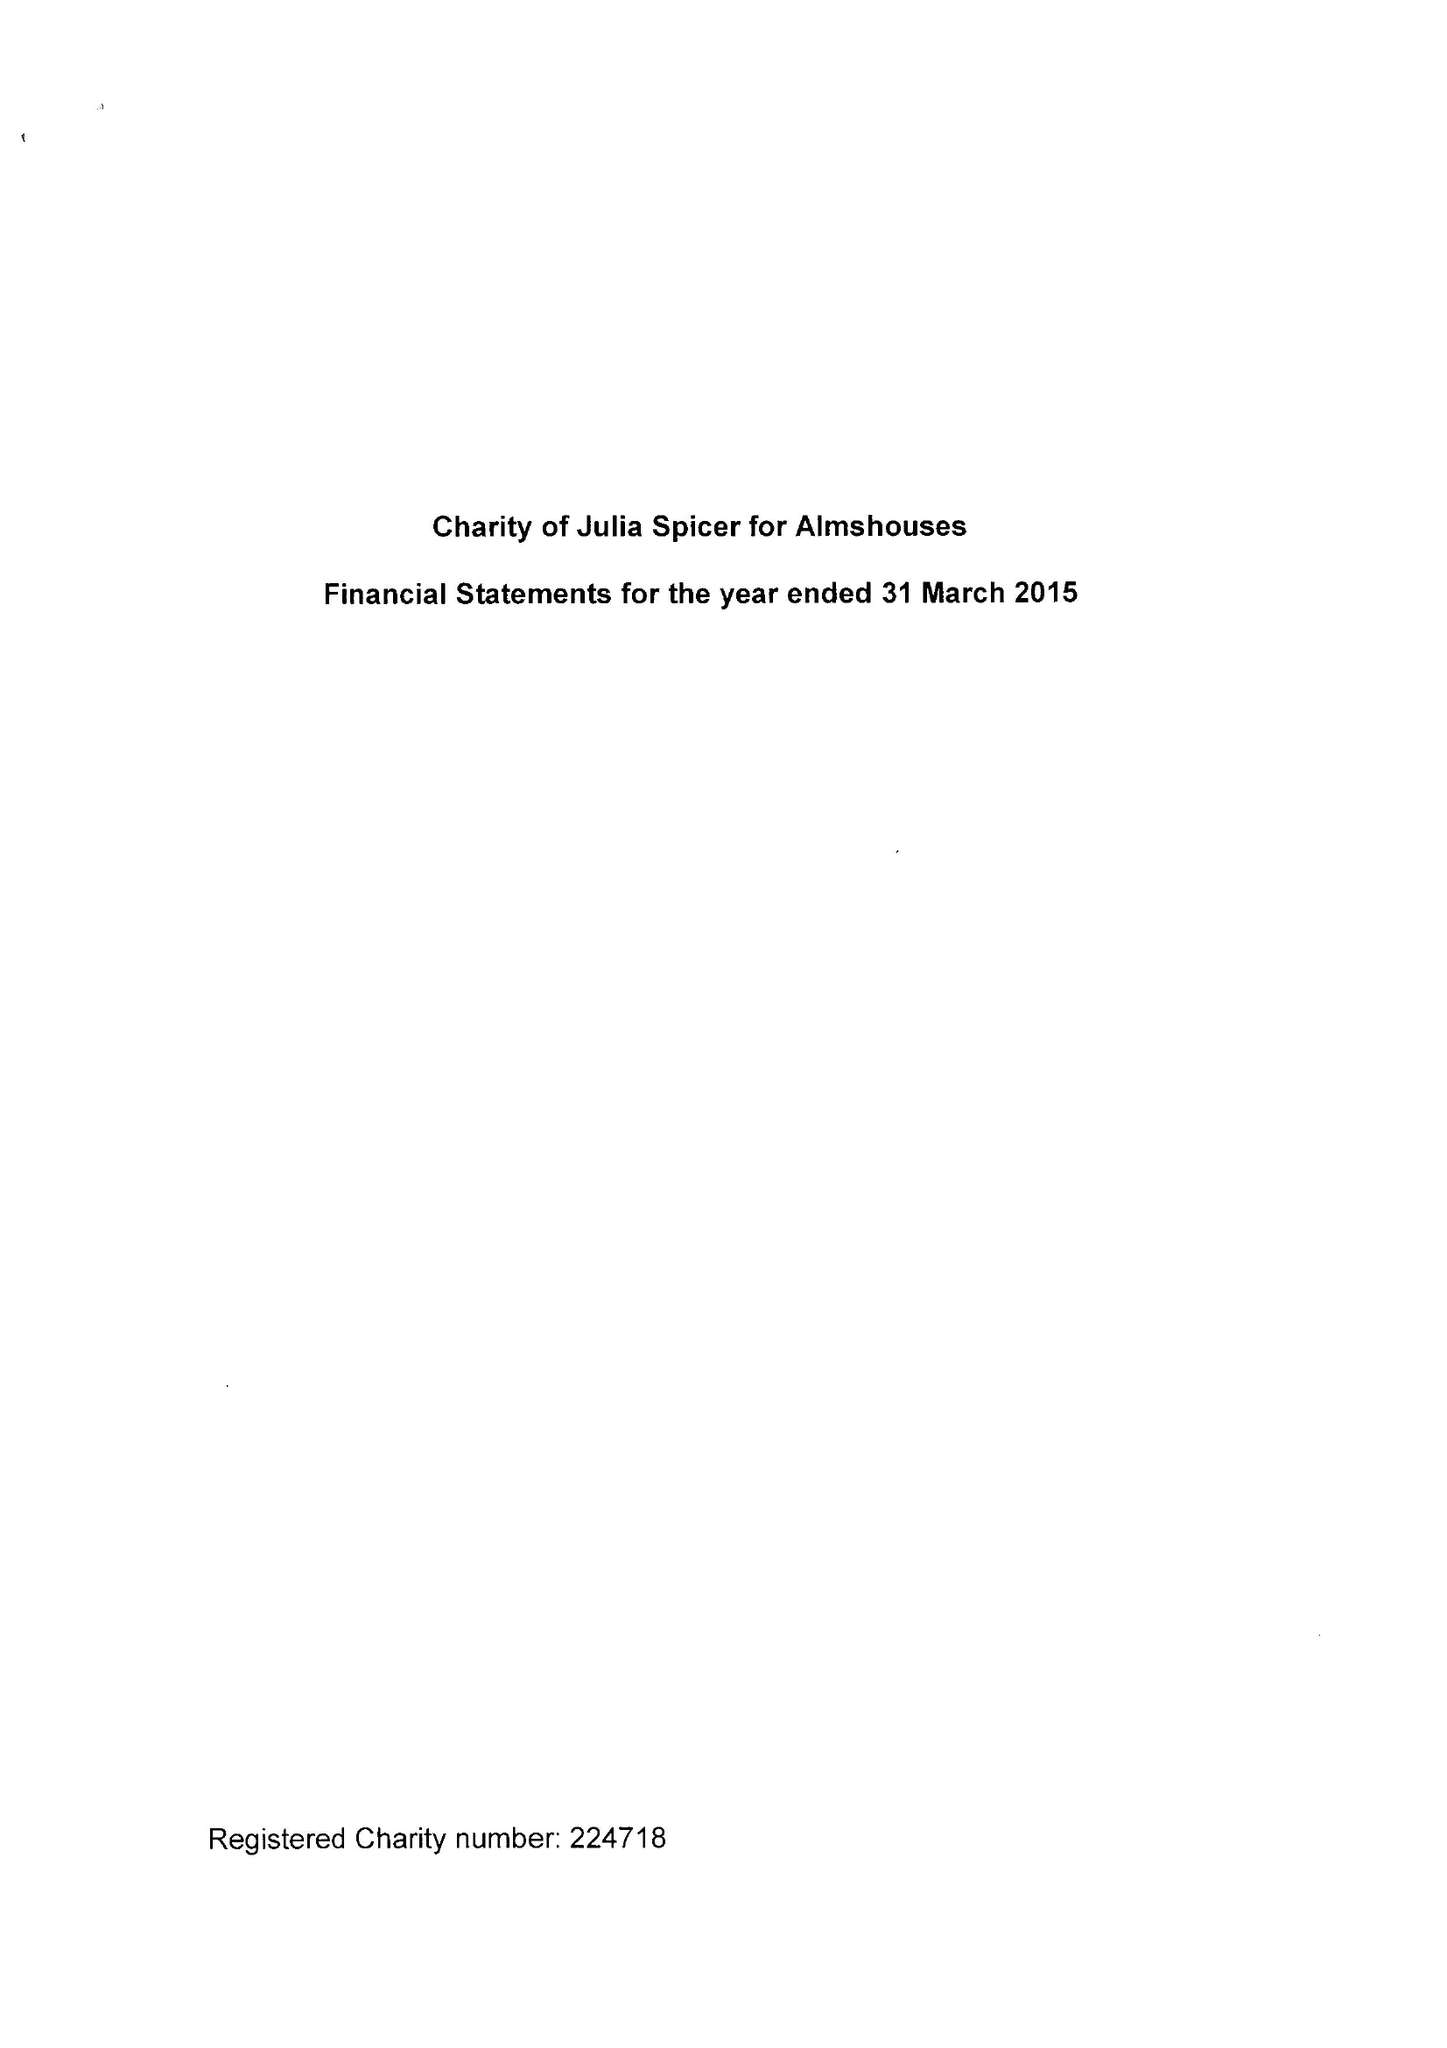What is the value for the address__street_line?
Answer the question using a single word or phrase. 125 HIGH STREET 